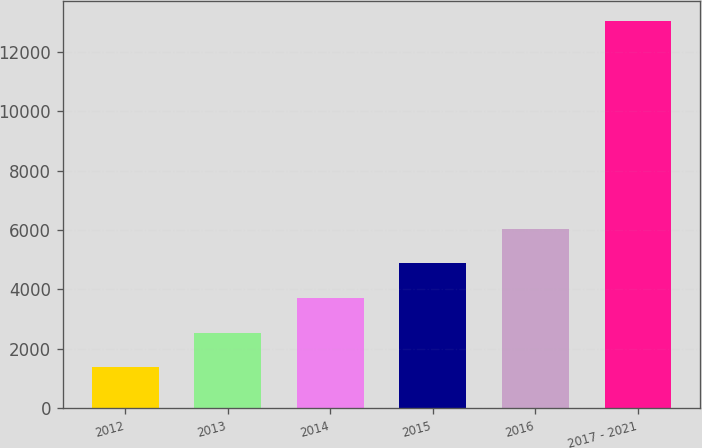Convert chart. <chart><loc_0><loc_0><loc_500><loc_500><bar_chart><fcel>2012<fcel>2013<fcel>2014<fcel>2015<fcel>2016<fcel>2017 - 2021<nl><fcel>1374<fcel>2542.4<fcel>3710.8<fcel>4879.2<fcel>6047.6<fcel>13058<nl></chart> 